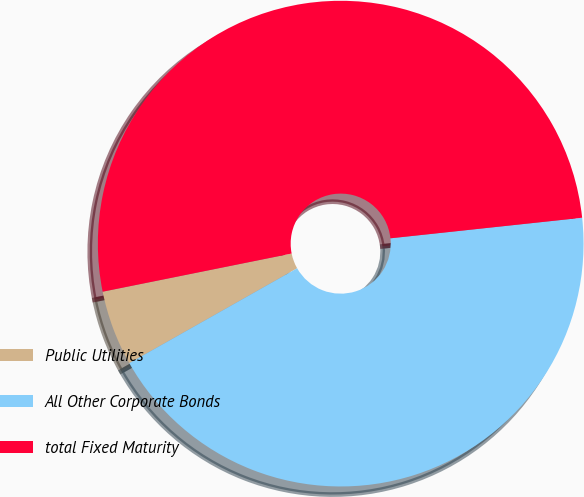Convert chart. <chart><loc_0><loc_0><loc_500><loc_500><pie_chart><fcel>Public Utilities<fcel>All Other Corporate Bonds<fcel>total Fixed Maturity<nl><fcel>5.02%<fcel>43.51%<fcel>51.47%<nl></chart> 